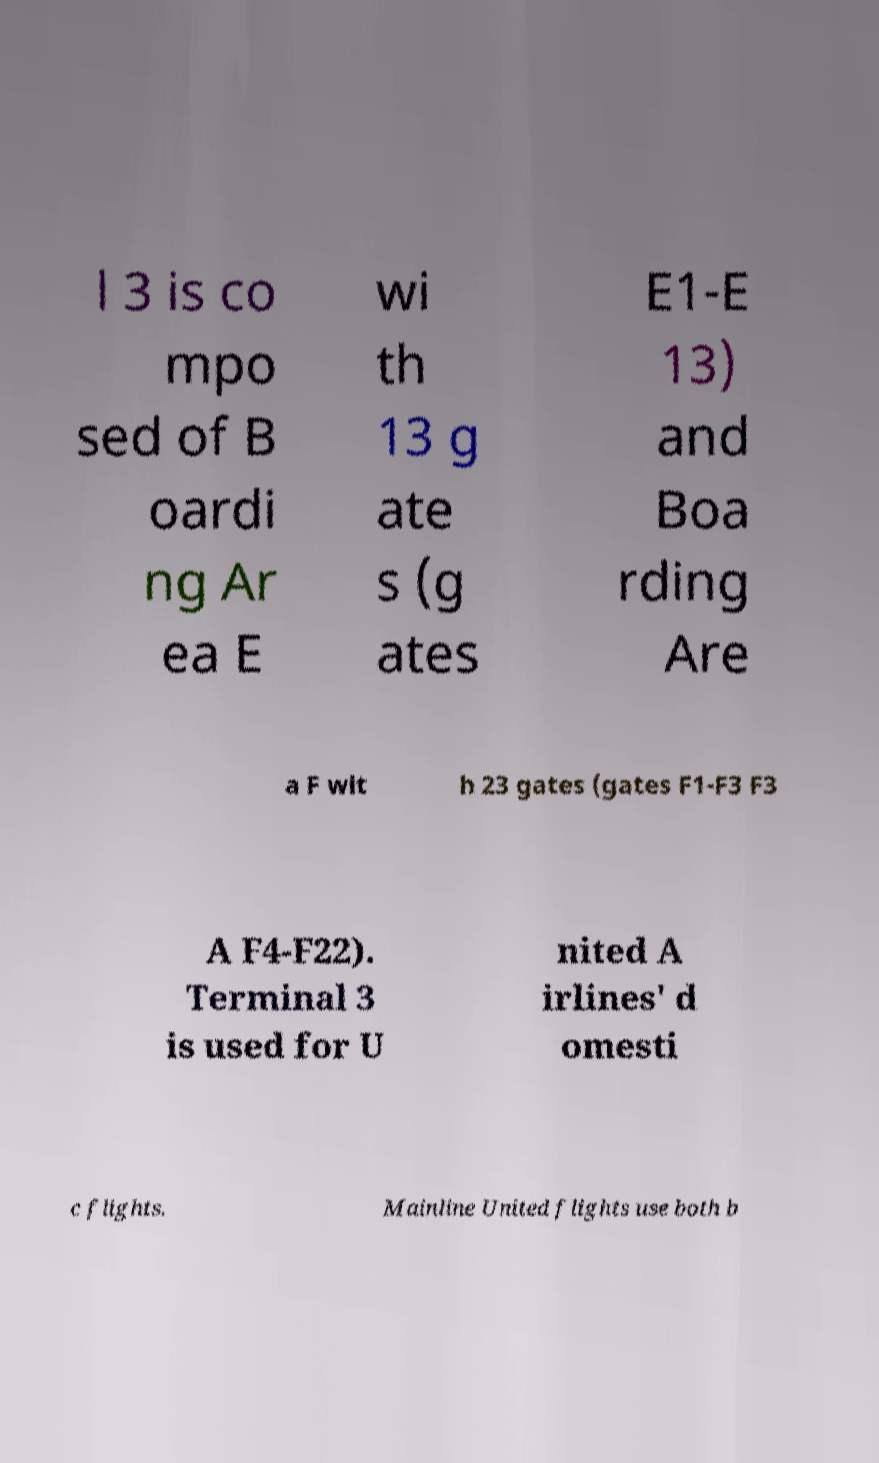There's text embedded in this image that I need extracted. Can you transcribe it verbatim? l 3 is co mpo sed of B oardi ng Ar ea E wi th 13 g ate s (g ates E1-E 13) and Boa rding Are a F wit h 23 gates (gates F1-F3 F3 A F4-F22). Terminal 3 is used for U nited A irlines' d omesti c flights. Mainline United flights use both b 